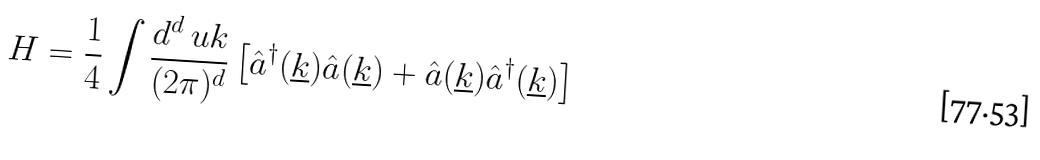Convert formula to latex. <formula><loc_0><loc_0><loc_500><loc_500>H = \frac { 1 } { 4 } \int \frac { d ^ { d } \ u k } { ( 2 \pi ) ^ { d } } \left [ \hat { a } ^ { \dagger } ( \underline { k } ) \hat { a } ( \underline { k } ) + \hat { a } ( \underline { k } ) \hat { a } ^ { \dagger } ( \underline { k } ) \right ]</formula> 